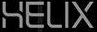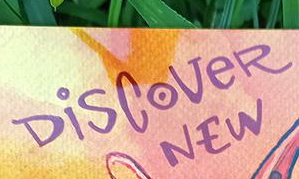What words can you see in these images in sequence, separated by a semicolon? HELIX; DiSCoVeR 